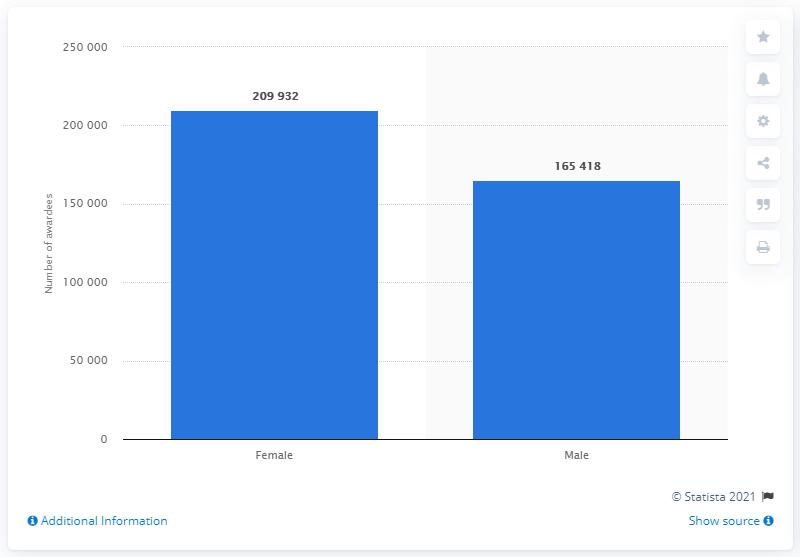Give some essential details in this illustration. In 2019, a total of 209,932 female students were awarded their undergraduate degrees in Karnataka. 